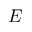<formula> <loc_0><loc_0><loc_500><loc_500>E</formula> 